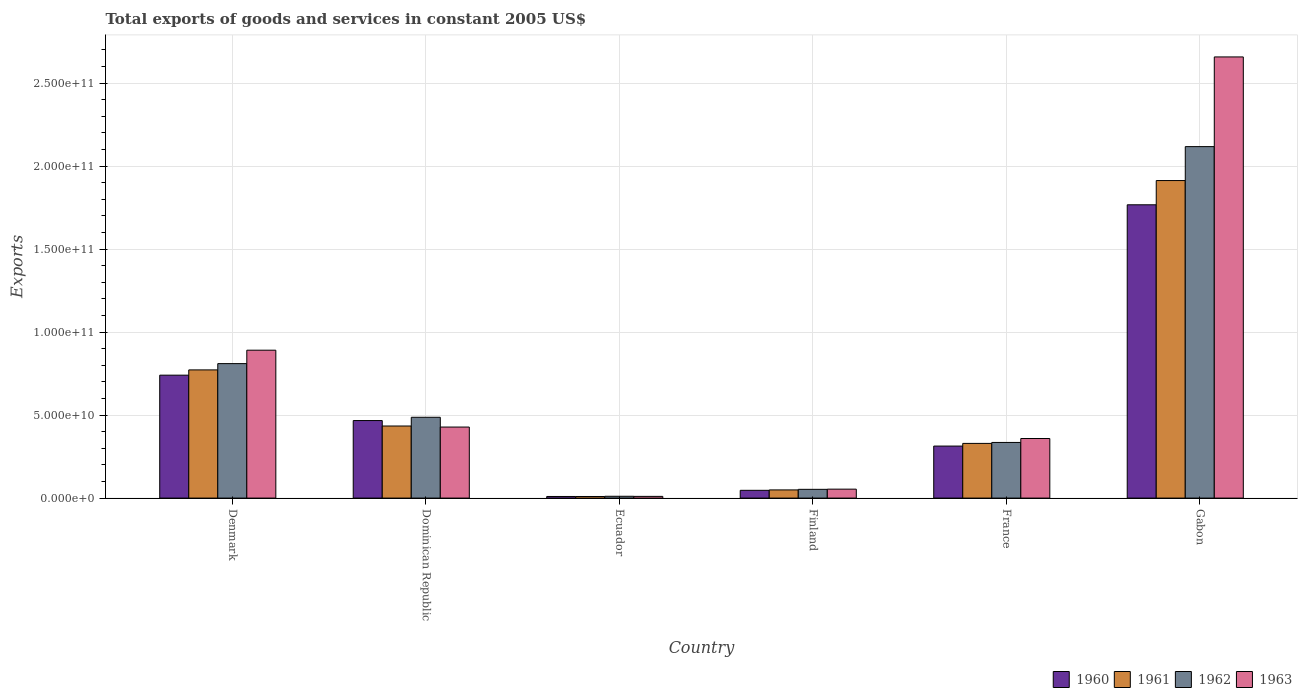How many different coloured bars are there?
Ensure brevity in your answer.  4. Are the number of bars per tick equal to the number of legend labels?
Offer a very short reply. Yes. What is the label of the 4th group of bars from the left?
Your answer should be compact. Finland. What is the total exports of goods and services in 1963 in France?
Provide a succinct answer. 3.59e+1. Across all countries, what is the maximum total exports of goods and services in 1960?
Offer a very short reply. 1.77e+11. Across all countries, what is the minimum total exports of goods and services in 1962?
Your answer should be compact. 1.09e+09. In which country was the total exports of goods and services in 1961 maximum?
Give a very brief answer. Gabon. In which country was the total exports of goods and services in 1961 minimum?
Ensure brevity in your answer.  Ecuador. What is the total total exports of goods and services in 1963 in the graph?
Keep it short and to the point. 4.40e+11. What is the difference between the total exports of goods and services in 1963 in Dominican Republic and that in France?
Provide a short and direct response. 6.90e+09. What is the difference between the total exports of goods and services in 1961 in Dominican Republic and the total exports of goods and services in 1960 in Ecuador?
Give a very brief answer. 4.24e+1. What is the average total exports of goods and services in 1962 per country?
Offer a very short reply. 6.35e+1. What is the difference between the total exports of goods and services of/in 1961 and total exports of goods and services of/in 1960 in Denmark?
Your answer should be compact. 3.17e+09. What is the ratio of the total exports of goods and services in 1962 in France to that in Gabon?
Provide a short and direct response. 0.16. What is the difference between the highest and the second highest total exports of goods and services in 1963?
Your response must be concise. -4.63e+1. What is the difference between the highest and the lowest total exports of goods and services in 1963?
Ensure brevity in your answer.  2.65e+11. Is the sum of the total exports of goods and services in 1963 in Finland and France greater than the maximum total exports of goods and services in 1960 across all countries?
Offer a terse response. No. What does the 3rd bar from the left in Dominican Republic represents?
Ensure brevity in your answer.  1962. What does the 2nd bar from the right in France represents?
Your response must be concise. 1962. How many bars are there?
Ensure brevity in your answer.  24. What is the difference between two consecutive major ticks on the Y-axis?
Your answer should be very brief. 5.00e+1. Are the values on the major ticks of Y-axis written in scientific E-notation?
Ensure brevity in your answer.  Yes. Does the graph contain any zero values?
Your response must be concise. No. Does the graph contain grids?
Your answer should be very brief. Yes. How are the legend labels stacked?
Provide a succinct answer. Horizontal. What is the title of the graph?
Offer a terse response. Total exports of goods and services in constant 2005 US$. What is the label or title of the X-axis?
Keep it short and to the point. Country. What is the label or title of the Y-axis?
Your answer should be very brief. Exports. What is the Exports in 1960 in Denmark?
Keep it short and to the point. 7.40e+1. What is the Exports of 1961 in Denmark?
Provide a short and direct response. 7.72e+1. What is the Exports of 1962 in Denmark?
Keep it short and to the point. 8.10e+1. What is the Exports in 1963 in Denmark?
Your answer should be very brief. 8.91e+1. What is the Exports of 1960 in Dominican Republic?
Give a very brief answer. 4.67e+1. What is the Exports in 1961 in Dominican Republic?
Provide a short and direct response. 4.34e+1. What is the Exports of 1962 in Dominican Republic?
Your answer should be compact. 4.87e+1. What is the Exports in 1963 in Dominican Republic?
Your answer should be compact. 4.28e+1. What is the Exports in 1960 in Ecuador?
Ensure brevity in your answer.  9.72e+08. What is the Exports of 1961 in Ecuador?
Keep it short and to the point. 9.65e+08. What is the Exports in 1962 in Ecuador?
Provide a succinct answer. 1.09e+09. What is the Exports of 1963 in Ecuador?
Provide a succinct answer. 1.03e+09. What is the Exports of 1960 in Finland?
Ensure brevity in your answer.  4.68e+09. What is the Exports in 1961 in Finland?
Make the answer very short. 4.92e+09. What is the Exports of 1962 in Finland?
Give a very brief answer. 5.27e+09. What is the Exports in 1963 in Finland?
Provide a succinct answer. 5.39e+09. What is the Exports in 1960 in France?
Make the answer very short. 3.13e+1. What is the Exports in 1961 in France?
Ensure brevity in your answer.  3.29e+1. What is the Exports in 1962 in France?
Your response must be concise. 3.35e+1. What is the Exports of 1963 in France?
Make the answer very short. 3.59e+1. What is the Exports of 1960 in Gabon?
Offer a very short reply. 1.77e+11. What is the Exports of 1961 in Gabon?
Your response must be concise. 1.91e+11. What is the Exports in 1962 in Gabon?
Make the answer very short. 2.12e+11. What is the Exports in 1963 in Gabon?
Provide a succinct answer. 2.66e+11. Across all countries, what is the maximum Exports of 1960?
Provide a succinct answer. 1.77e+11. Across all countries, what is the maximum Exports in 1961?
Keep it short and to the point. 1.91e+11. Across all countries, what is the maximum Exports of 1962?
Give a very brief answer. 2.12e+11. Across all countries, what is the maximum Exports in 1963?
Your answer should be very brief. 2.66e+11. Across all countries, what is the minimum Exports in 1960?
Offer a terse response. 9.72e+08. Across all countries, what is the minimum Exports of 1961?
Make the answer very short. 9.65e+08. Across all countries, what is the minimum Exports of 1962?
Your answer should be very brief. 1.09e+09. Across all countries, what is the minimum Exports of 1963?
Offer a terse response. 1.03e+09. What is the total Exports of 1960 in the graph?
Keep it short and to the point. 3.34e+11. What is the total Exports of 1961 in the graph?
Keep it short and to the point. 3.51e+11. What is the total Exports of 1962 in the graph?
Provide a succinct answer. 3.81e+11. What is the total Exports of 1963 in the graph?
Ensure brevity in your answer.  4.40e+11. What is the difference between the Exports of 1960 in Denmark and that in Dominican Republic?
Your answer should be compact. 2.73e+1. What is the difference between the Exports in 1961 in Denmark and that in Dominican Republic?
Give a very brief answer. 3.38e+1. What is the difference between the Exports of 1962 in Denmark and that in Dominican Republic?
Ensure brevity in your answer.  3.23e+1. What is the difference between the Exports of 1963 in Denmark and that in Dominican Republic?
Your response must be concise. 4.63e+1. What is the difference between the Exports of 1960 in Denmark and that in Ecuador?
Offer a terse response. 7.31e+1. What is the difference between the Exports of 1961 in Denmark and that in Ecuador?
Give a very brief answer. 7.62e+1. What is the difference between the Exports of 1962 in Denmark and that in Ecuador?
Make the answer very short. 7.99e+1. What is the difference between the Exports of 1963 in Denmark and that in Ecuador?
Offer a very short reply. 8.81e+1. What is the difference between the Exports in 1960 in Denmark and that in Finland?
Your answer should be compact. 6.94e+1. What is the difference between the Exports of 1961 in Denmark and that in Finland?
Make the answer very short. 7.23e+1. What is the difference between the Exports of 1962 in Denmark and that in Finland?
Your answer should be very brief. 7.57e+1. What is the difference between the Exports in 1963 in Denmark and that in Finland?
Keep it short and to the point. 8.37e+1. What is the difference between the Exports in 1960 in Denmark and that in France?
Your answer should be compact. 4.27e+1. What is the difference between the Exports of 1961 in Denmark and that in France?
Provide a short and direct response. 4.43e+1. What is the difference between the Exports in 1962 in Denmark and that in France?
Your answer should be very brief. 4.75e+1. What is the difference between the Exports of 1963 in Denmark and that in France?
Offer a terse response. 5.32e+1. What is the difference between the Exports in 1960 in Denmark and that in Gabon?
Offer a very short reply. -1.03e+11. What is the difference between the Exports in 1961 in Denmark and that in Gabon?
Provide a succinct answer. -1.14e+11. What is the difference between the Exports in 1962 in Denmark and that in Gabon?
Provide a short and direct response. -1.31e+11. What is the difference between the Exports of 1963 in Denmark and that in Gabon?
Your answer should be very brief. -1.77e+11. What is the difference between the Exports of 1960 in Dominican Republic and that in Ecuador?
Give a very brief answer. 4.57e+1. What is the difference between the Exports of 1961 in Dominican Republic and that in Ecuador?
Your response must be concise. 4.25e+1. What is the difference between the Exports in 1962 in Dominican Republic and that in Ecuador?
Your answer should be very brief. 4.76e+1. What is the difference between the Exports of 1963 in Dominican Republic and that in Ecuador?
Your response must be concise. 4.18e+1. What is the difference between the Exports in 1960 in Dominican Republic and that in Finland?
Your answer should be compact. 4.20e+1. What is the difference between the Exports of 1961 in Dominican Republic and that in Finland?
Keep it short and to the point. 3.85e+1. What is the difference between the Exports of 1962 in Dominican Republic and that in Finland?
Offer a terse response. 4.34e+1. What is the difference between the Exports in 1963 in Dominican Republic and that in Finland?
Provide a short and direct response. 3.74e+1. What is the difference between the Exports in 1960 in Dominican Republic and that in France?
Offer a terse response. 1.54e+1. What is the difference between the Exports of 1961 in Dominican Republic and that in France?
Your response must be concise. 1.05e+1. What is the difference between the Exports of 1962 in Dominican Republic and that in France?
Offer a terse response. 1.52e+1. What is the difference between the Exports of 1963 in Dominican Republic and that in France?
Your response must be concise. 6.90e+09. What is the difference between the Exports of 1960 in Dominican Republic and that in Gabon?
Make the answer very short. -1.30e+11. What is the difference between the Exports of 1961 in Dominican Republic and that in Gabon?
Offer a very short reply. -1.48e+11. What is the difference between the Exports in 1962 in Dominican Republic and that in Gabon?
Your answer should be compact. -1.63e+11. What is the difference between the Exports of 1963 in Dominican Republic and that in Gabon?
Give a very brief answer. -2.23e+11. What is the difference between the Exports of 1960 in Ecuador and that in Finland?
Make the answer very short. -3.71e+09. What is the difference between the Exports in 1961 in Ecuador and that in Finland?
Give a very brief answer. -3.96e+09. What is the difference between the Exports in 1962 in Ecuador and that in Finland?
Your answer should be compact. -4.18e+09. What is the difference between the Exports in 1963 in Ecuador and that in Finland?
Keep it short and to the point. -4.36e+09. What is the difference between the Exports in 1960 in Ecuador and that in France?
Provide a succinct answer. -3.04e+1. What is the difference between the Exports in 1961 in Ecuador and that in France?
Offer a terse response. -3.20e+1. What is the difference between the Exports of 1962 in Ecuador and that in France?
Your response must be concise. -3.24e+1. What is the difference between the Exports in 1963 in Ecuador and that in France?
Ensure brevity in your answer.  -3.49e+1. What is the difference between the Exports of 1960 in Ecuador and that in Gabon?
Your response must be concise. -1.76e+11. What is the difference between the Exports of 1961 in Ecuador and that in Gabon?
Ensure brevity in your answer.  -1.90e+11. What is the difference between the Exports in 1962 in Ecuador and that in Gabon?
Ensure brevity in your answer.  -2.11e+11. What is the difference between the Exports in 1963 in Ecuador and that in Gabon?
Ensure brevity in your answer.  -2.65e+11. What is the difference between the Exports in 1960 in Finland and that in France?
Your response must be concise. -2.67e+1. What is the difference between the Exports of 1961 in Finland and that in France?
Ensure brevity in your answer.  -2.80e+1. What is the difference between the Exports of 1962 in Finland and that in France?
Ensure brevity in your answer.  -2.83e+1. What is the difference between the Exports of 1963 in Finland and that in France?
Ensure brevity in your answer.  -3.05e+1. What is the difference between the Exports in 1960 in Finland and that in Gabon?
Make the answer very short. -1.72e+11. What is the difference between the Exports of 1961 in Finland and that in Gabon?
Ensure brevity in your answer.  -1.86e+11. What is the difference between the Exports in 1962 in Finland and that in Gabon?
Offer a terse response. -2.06e+11. What is the difference between the Exports of 1963 in Finland and that in Gabon?
Your answer should be compact. -2.60e+11. What is the difference between the Exports in 1960 in France and that in Gabon?
Make the answer very short. -1.45e+11. What is the difference between the Exports of 1961 in France and that in Gabon?
Your answer should be very brief. -1.58e+11. What is the difference between the Exports of 1962 in France and that in Gabon?
Your answer should be very brief. -1.78e+11. What is the difference between the Exports of 1963 in France and that in Gabon?
Offer a terse response. -2.30e+11. What is the difference between the Exports of 1960 in Denmark and the Exports of 1961 in Dominican Republic?
Offer a very short reply. 3.06e+1. What is the difference between the Exports of 1960 in Denmark and the Exports of 1962 in Dominican Republic?
Make the answer very short. 2.54e+1. What is the difference between the Exports in 1960 in Denmark and the Exports in 1963 in Dominican Republic?
Your response must be concise. 3.13e+1. What is the difference between the Exports in 1961 in Denmark and the Exports in 1962 in Dominican Republic?
Your answer should be compact. 2.85e+1. What is the difference between the Exports in 1961 in Denmark and the Exports in 1963 in Dominican Republic?
Make the answer very short. 3.44e+1. What is the difference between the Exports of 1962 in Denmark and the Exports of 1963 in Dominican Republic?
Make the answer very short. 3.82e+1. What is the difference between the Exports of 1960 in Denmark and the Exports of 1961 in Ecuador?
Ensure brevity in your answer.  7.31e+1. What is the difference between the Exports of 1960 in Denmark and the Exports of 1962 in Ecuador?
Your answer should be compact. 7.30e+1. What is the difference between the Exports in 1960 in Denmark and the Exports in 1963 in Ecuador?
Your response must be concise. 7.30e+1. What is the difference between the Exports in 1961 in Denmark and the Exports in 1962 in Ecuador?
Offer a very short reply. 7.61e+1. What is the difference between the Exports of 1961 in Denmark and the Exports of 1963 in Ecuador?
Give a very brief answer. 7.62e+1. What is the difference between the Exports in 1962 in Denmark and the Exports in 1963 in Ecuador?
Your answer should be compact. 8.00e+1. What is the difference between the Exports of 1960 in Denmark and the Exports of 1961 in Finland?
Your answer should be compact. 6.91e+1. What is the difference between the Exports of 1960 in Denmark and the Exports of 1962 in Finland?
Provide a short and direct response. 6.88e+1. What is the difference between the Exports in 1960 in Denmark and the Exports in 1963 in Finland?
Provide a short and direct response. 6.87e+1. What is the difference between the Exports in 1961 in Denmark and the Exports in 1962 in Finland?
Ensure brevity in your answer.  7.19e+1. What is the difference between the Exports of 1961 in Denmark and the Exports of 1963 in Finland?
Offer a very short reply. 7.18e+1. What is the difference between the Exports in 1962 in Denmark and the Exports in 1963 in Finland?
Your response must be concise. 7.56e+1. What is the difference between the Exports of 1960 in Denmark and the Exports of 1961 in France?
Keep it short and to the point. 4.11e+1. What is the difference between the Exports in 1960 in Denmark and the Exports in 1962 in France?
Ensure brevity in your answer.  4.05e+1. What is the difference between the Exports of 1960 in Denmark and the Exports of 1963 in France?
Ensure brevity in your answer.  3.82e+1. What is the difference between the Exports of 1961 in Denmark and the Exports of 1962 in France?
Provide a short and direct response. 4.37e+1. What is the difference between the Exports in 1961 in Denmark and the Exports in 1963 in France?
Give a very brief answer. 4.13e+1. What is the difference between the Exports in 1962 in Denmark and the Exports in 1963 in France?
Offer a very short reply. 4.51e+1. What is the difference between the Exports of 1960 in Denmark and the Exports of 1961 in Gabon?
Offer a terse response. -1.17e+11. What is the difference between the Exports of 1960 in Denmark and the Exports of 1962 in Gabon?
Provide a short and direct response. -1.38e+11. What is the difference between the Exports of 1960 in Denmark and the Exports of 1963 in Gabon?
Offer a very short reply. -1.92e+11. What is the difference between the Exports in 1961 in Denmark and the Exports in 1962 in Gabon?
Make the answer very short. -1.34e+11. What is the difference between the Exports in 1961 in Denmark and the Exports in 1963 in Gabon?
Offer a very short reply. -1.89e+11. What is the difference between the Exports of 1962 in Denmark and the Exports of 1963 in Gabon?
Keep it short and to the point. -1.85e+11. What is the difference between the Exports in 1960 in Dominican Republic and the Exports in 1961 in Ecuador?
Your answer should be very brief. 4.57e+1. What is the difference between the Exports of 1960 in Dominican Republic and the Exports of 1962 in Ecuador?
Your answer should be compact. 4.56e+1. What is the difference between the Exports in 1960 in Dominican Republic and the Exports in 1963 in Ecuador?
Keep it short and to the point. 4.57e+1. What is the difference between the Exports of 1961 in Dominican Republic and the Exports of 1962 in Ecuador?
Ensure brevity in your answer.  4.23e+1. What is the difference between the Exports of 1961 in Dominican Republic and the Exports of 1963 in Ecuador?
Provide a short and direct response. 4.24e+1. What is the difference between the Exports of 1962 in Dominican Republic and the Exports of 1963 in Ecuador?
Provide a succinct answer. 4.77e+1. What is the difference between the Exports of 1960 in Dominican Republic and the Exports of 1961 in Finland?
Keep it short and to the point. 4.18e+1. What is the difference between the Exports of 1960 in Dominican Republic and the Exports of 1962 in Finland?
Provide a succinct answer. 4.14e+1. What is the difference between the Exports in 1960 in Dominican Republic and the Exports in 1963 in Finland?
Your response must be concise. 4.13e+1. What is the difference between the Exports of 1961 in Dominican Republic and the Exports of 1962 in Finland?
Offer a very short reply. 3.81e+1. What is the difference between the Exports of 1961 in Dominican Republic and the Exports of 1963 in Finland?
Offer a terse response. 3.80e+1. What is the difference between the Exports of 1962 in Dominican Republic and the Exports of 1963 in Finland?
Offer a very short reply. 4.33e+1. What is the difference between the Exports in 1960 in Dominican Republic and the Exports in 1961 in France?
Offer a terse response. 1.38e+1. What is the difference between the Exports in 1960 in Dominican Republic and the Exports in 1962 in France?
Your answer should be compact. 1.32e+1. What is the difference between the Exports of 1960 in Dominican Republic and the Exports of 1963 in France?
Give a very brief answer. 1.08e+1. What is the difference between the Exports in 1961 in Dominican Republic and the Exports in 1962 in France?
Give a very brief answer. 9.89e+09. What is the difference between the Exports in 1961 in Dominican Republic and the Exports in 1963 in France?
Your answer should be compact. 7.53e+09. What is the difference between the Exports of 1962 in Dominican Republic and the Exports of 1963 in France?
Your answer should be very brief. 1.28e+1. What is the difference between the Exports in 1960 in Dominican Republic and the Exports in 1961 in Gabon?
Your answer should be very brief. -1.45e+11. What is the difference between the Exports in 1960 in Dominican Republic and the Exports in 1962 in Gabon?
Give a very brief answer. -1.65e+11. What is the difference between the Exports of 1960 in Dominican Republic and the Exports of 1963 in Gabon?
Keep it short and to the point. -2.19e+11. What is the difference between the Exports in 1961 in Dominican Republic and the Exports in 1962 in Gabon?
Provide a succinct answer. -1.68e+11. What is the difference between the Exports of 1961 in Dominican Republic and the Exports of 1963 in Gabon?
Give a very brief answer. -2.22e+11. What is the difference between the Exports of 1962 in Dominican Republic and the Exports of 1963 in Gabon?
Your answer should be compact. -2.17e+11. What is the difference between the Exports in 1960 in Ecuador and the Exports in 1961 in Finland?
Offer a terse response. -3.95e+09. What is the difference between the Exports in 1960 in Ecuador and the Exports in 1962 in Finland?
Give a very brief answer. -4.30e+09. What is the difference between the Exports in 1960 in Ecuador and the Exports in 1963 in Finland?
Ensure brevity in your answer.  -4.41e+09. What is the difference between the Exports of 1961 in Ecuador and the Exports of 1962 in Finland?
Your response must be concise. -4.31e+09. What is the difference between the Exports in 1961 in Ecuador and the Exports in 1963 in Finland?
Your response must be concise. -4.42e+09. What is the difference between the Exports in 1962 in Ecuador and the Exports in 1963 in Finland?
Give a very brief answer. -4.29e+09. What is the difference between the Exports of 1960 in Ecuador and the Exports of 1961 in France?
Offer a very short reply. -3.20e+1. What is the difference between the Exports of 1960 in Ecuador and the Exports of 1962 in France?
Keep it short and to the point. -3.25e+1. What is the difference between the Exports in 1960 in Ecuador and the Exports in 1963 in France?
Make the answer very short. -3.49e+1. What is the difference between the Exports of 1961 in Ecuador and the Exports of 1962 in France?
Provide a succinct answer. -3.26e+1. What is the difference between the Exports of 1961 in Ecuador and the Exports of 1963 in France?
Provide a short and direct response. -3.49e+1. What is the difference between the Exports in 1962 in Ecuador and the Exports in 1963 in France?
Provide a succinct answer. -3.48e+1. What is the difference between the Exports of 1960 in Ecuador and the Exports of 1961 in Gabon?
Offer a very short reply. -1.90e+11. What is the difference between the Exports in 1960 in Ecuador and the Exports in 1962 in Gabon?
Offer a terse response. -2.11e+11. What is the difference between the Exports of 1960 in Ecuador and the Exports of 1963 in Gabon?
Your answer should be compact. -2.65e+11. What is the difference between the Exports in 1961 in Ecuador and the Exports in 1962 in Gabon?
Your answer should be compact. -2.11e+11. What is the difference between the Exports of 1961 in Ecuador and the Exports of 1963 in Gabon?
Provide a succinct answer. -2.65e+11. What is the difference between the Exports of 1962 in Ecuador and the Exports of 1963 in Gabon?
Offer a very short reply. -2.65e+11. What is the difference between the Exports of 1960 in Finland and the Exports of 1961 in France?
Make the answer very short. -2.83e+1. What is the difference between the Exports of 1960 in Finland and the Exports of 1962 in France?
Provide a succinct answer. -2.88e+1. What is the difference between the Exports in 1960 in Finland and the Exports in 1963 in France?
Keep it short and to the point. -3.12e+1. What is the difference between the Exports in 1961 in Finland and the Exports in 1962 in France?
Ensure brevity in your answer.  -2.86e+1. What is the difference between the Exports of 1961 in Finland and the Exports of 1963 in France?
Provide a short and direct response. -3.10e+1. What is the difference between the Exports of 1962 in Finland and the Exports of 1963 in France?
Your response must be concise. -3.06e+1. What is the difference between the Exports in 1960 in Finland and the Exports in 1961 in Gabon?
Your answer should be very brief. -1.87e+11. What is the difference between the Exports in 1960 in Finland and the Exports in 1962 in Gabon?
Your answer should be very brief. -2.07e+11. What is the difference between the Exports of 1960 in Finland and the Exports of 1963 in Gabon?
Your answer should be compact. -2.61e+11. What is the difference between the Exports of 1961 in Finland and the Exports of 1962 in Gabon?
Offer a terse response. -2.07e+11. What is the difference between the Exports of 1961 in Finland and the Exports of 1963 in Gabon?
Provide a short and direct response. -2.61e+11. What is the difference between the Exports in 1962 in Finland and the Exports in 1963 in Gabon?
Ensure brevity in your answer.  -2.60e+11. What is the difference between the Exports in 1960 in France and the Exports in 1961 in Gabon?
Your answer should be very brief. -1.60e+11. What is the difference between the Exports of 1960 in France and the Exports of 1962 in Gabon?
Your answer should be very brief. -1.80e+11. What is the difference between the Exports in 1960 in France and the Exports in 1963 in Gabon?
Your answer should be very brief. -2.34e+11. What is the difference between the Exports in 1961 in France and the Exports in 1962 in Gabon?
Make the answer very short. -1.79e+11. What is the difference between the Exports of 1961 in France and the Exports of 1963 in Gabon?
Make the answer very short. -2.33e+11. What is the difference between the Exports of 1962 in France and the Exports of 1963 in Gabon?
Keep it short and to the point. -2.32e+11. What is the average Exports in 1960 per country?
Keep it short and to the point. 5.57e+1. What is the average Exports of 1961 per country?
Offer a terse response. 5.85e+1. What is the average Exports of 1962 per country?
Give a very brief answer. 6.35e+1. What is the average Exports of 1963 per country?
Your answer should be very brief. 7.33e+1. What is the difference between the Exports in 1960 and Exports in 1961 in Denmark?
Your response must be concise. -3.17e+09. What is the difference between the Exports in 1960 and Exports in 1962 in Denmark?
Make the answer very short. -6.96e+09. What is the difference between the Exports of 1960 and Exports of 1963 in Denmark?
Your answer should be compact. -1.50e+1. What is the difference between the Exports in 1961 and Exports in 1962 in Denmark?
Offer a terse response. -3.79e+09. What is the difference between the Exports in 1961 and Exports in 1963 in Denmark?
Make the answer very short. -1.19e+1. What is the difference between the Exports in 1962 and Exports in 1963 in Denmark?
Your answer should be compact. -8.08e+09. What is the difference between the Exports in 1960 and Exports in 1961 in Dominican Republic?
Keep it short and to the point. 3.29e+09. What is the difference between the Exports in 1960 and Exports in 1962 in Dominican Republic?
Make the answer very short. -1.98e+09. What is the difference between the Exports of 1960 and Exports of 1963 in Dominican Republic?
Provide a succinct answer. 3.92e+09. What is the difference between the Exports in 1961 and Exports in 1962 in Dominican Republic?
Give a very brief answer. -5.27e+09. What is the difference between the Exports of 1961 and Exports of 1963 in Dominican Republic?
Your answer should be compact. 6.26e+08. What is the difference between the Exports in 1962 and Exports in 1963 in Dominican Republic?
Provide a succinct answer. 5.89e+09. What is the difference between the Exports of 1960 and Exports of 1961 in Ecuador?
Your response must be concise. 7.18e+06. What is the difference between the Exports of 1960 and Exports of 1962 in Ecuador?
Give a very brief answer. -1.22e+08. What is the difference between the Exports in 1960 and Exports in 1963 in Ecuador?
Provide a succinct answer. -5.99e+07. What is the difference between the Exports of 1961 and Exports of 1962 in Ecuador?
Your response must be concise. -1.29e+08. What is the difference between the Exports of 1961 and Exports of 1963 in Ecuador?
Give a very brief answer. -6.70e+07. What is the difference between the Exports of 1962 and Exports of 1963 in Ecuador?
Make the answer very short. 6.23e+07. What is the difference between the Exports in 1960 and Exports in 1961 in Finland?
Your answer should be very brief. -2.41e+08. What is the difference between the Exports in 1960 and Exports in 1962 in Finland?
Give a very brief answer. -5.89e+08. What is the difference between the Exports in 1960 and Exports in 1963 in Finland?
Give a very brief answer. -7.04e+08. What is the difference between the Exports in 1961 and Exports in 1962 in Finland?
Your answer should be compact. -3.48e+08. What is the difference between the Exports in 1961 and Exports in 1963 in Finland?
Ensure brevity in your answer.  -4.64e+08. What is the difference between the Exports in 1962 and Exports in 1963 in Finland?
Offer a very short reply. -1.15e+08. What is the difference between the Exports of 1960 and Exports of 1961 in France?
Keep it short and to the point. -1.60e+09. What is the difference between the Exports in 1960 and Exports in 1962 in France?
Your answer should be compact. -2.19e+09. What is the difference between the Exports in 1960 and Exports in 1963 in France?
Your answer should be very brief. -4.55e+09. What is the difference between the Exports of 1961 and Exports of 1962 in France?
Your answer should be compact. -5.82e+08. What is the difference between the Exports of 1961 and Exports of 1963 in France?
Your response must be concise. -2.95e+09. What is the difference between the Exports in 1962 and Exports in 1963 in France?
Give a very brief answer. -2.37e+09. What is the difference between the Exports in 1960 and Exports in 1961 in Gabon?
Your response must be concise. -1.46e+1. What is the difference between the Exports of 1960 and Exports of 1962 in Gabon?
Your answer should be very brief. -3.50e+1. What is the difference between the Exports of 1960 and Exports of 1963 in Gabon?
Provide a succinct answer. -8.91e+1. What is the difference between the Exports of 1961 and Exports of 1962 in Gabon?
Give a very brief answer. -2.04e+1. What is the difference between the Exports of 1961 and Exports of 1963 in Gabon?
Your response must be concise. -7.45e+1. What is the difference between the Exports of 1962 and Exports of 1963 in Gabon?
Your answer should be very brief. -5.40e+1. What is the ratio of the Exports of 1960 in Denmark to that in Dominican Republic?
Offer a terse response. 1.59. What is the ratio of the Exports of 1961 in Denmark to that in Dominican Republic?
Offer a very short reply. 1.78. What is the ratio of the Exports of 1962 in Denmark to that in Dominican Republic?
Provide a short and direct response. 1.66. What is the ratio of the Exports of 1963 in Denmark to that in Dominican Republic?
Your response must be concise. 2.08. What is the ratio of the Exports of 1960 in Denmark to that in Ecuador?
Provide a succinct answer. 76.17. What is the ratio of the Exports of 1961 in Denmark to that in Ecuador?
Ensure brevity in your answer.  80.01. What is the ratio of the Exports in 1962 in Denmark to that in Ecuador?
Offer a terse response. 74.02. What is the ratio of the Exports of 1963 in Denmark to that in Ecuador?
Offer a very short reply. 86.32. What is the ratio of the Exports of 1960 in Denmark to that in Finland?
Provide a short and direct response. 15.81. What is the ratio of the Exports in 1961 in Denmark to that in Finland?
Keep it short and to the point. 15.68. What is the ratio of the Exports in 1962 in Denmark to that in Finland?
Ensure brevity in your answer.  15.37. What is the ratio of the Exports of 1963 in Denmark to that in Finland?
Offer a terse response. 16.54. What is the ratio of the Exports in 1960 in Denmark to that in France?
Give a very brief answer. 2.36. What is the ratio of the Exports of 1961 in Denmark to that in France?
Your answer should be compact. 2.34. What is the ratio of the Exports of 1962 in Denmark to that in France?
Your response must be concise. 2.42. What is the ratio of the Exports in 1963 in Denmark to that in France?
Ensure brevity in your answer.  2.48. What is the ratio of the Exports of 1960 in Denmark to that in Gabon?
Your answer should be very brief. 0.42. What is the ratio of the Exports of 1961 in Denmark to that in Gabon?
Offer a very short reply. 0.4. What is the ratio of the Exports of 1962 in Denmark to that in Gabon?
Your answer should be compact. 0.38. What is the ratio of the Exports of 1963 in Denmark to that in Gabon?
Make the answer very short. 0.34. What is the ratio of the Exports in 1960 in Dominican Republic to that in Ecuador?
Your answer should be very brief. 48.04. What is the ratio of the Exports of 1961 in Dominican Republic to that in Ecuador?
Give a very brief answer. 44.99. What is the ratio of the Exports in 1962 in Dominican Republic to that in Ecuador?
Offer a very short reply. 44.49. What is the ratio of the Exports in 1963 in Dominican Republic to that in Ecuador?
Offer a very short reply. 41.46. What is the ratio of the Exports in 1960 in Dominican Republic to that in Finland?
Offer a terse response. 9.97. What is the ratio of the Exports of 1961 in Dominican Republic to that in Finland?
Your response must be concise. 8.82. What is the ratio of the Exports in 1962 in Dominican Republic to that in Finland?
Your response must be concise. 9.23. What is the ratio of the Exports of 1963 in Dominican Republic to that in Finland?
Offer a very short reply. 7.94. What is the ratio of the Exports in 1960 in Dominican Republic to that in France?
Make the answer very short. 1.49. What is the ratio of the Exports of 1961 in Dominican Republic to that in France?
Keep it short and to the point. 1.32. What is the ratio of the Exports in 1962 in Dominican Republic to that in France?
Give a very brief answer. 1.45. What is the ratio of the Exports of 1963 in Dominican Republic to that in France?
Your answer should be very brief. 1.19. What is the ratio of the Exports in 1960 in Dominican Republic to that in Gabon?
Your answer should be very brief. 0.26. What is the ratio of the Exports of 1961 in Dominican Republic to that in Gabon?
Your response must be concise. 0.23. What is the ratio of the Exports in 1962 in Dominican Republic to that in Gabon?
Your response must be concise. 0.23. What is the ratio of the Exports of 1963 in Dominican Republic to that in Gabon?
Offer a terse response. 0.16. What is the ratio of the Exports of 1960 in Ecuador to that in Finland?
Give a very brief answer. 0.21. What is the ratio of the Exports of 1961 in Ecuador to that in Finland?
Keep it short and to the point. 0.2. What is the ratio of the Exports of 1962 in Ecuador to that in Finland?
Your answer should be compact. 0.21. What is the ratio of the Exports in 1963 in Ecuador to that in Finland?
Keep it short and to the point. 0.19. What is the ratio of the Exports of 1960 in Ecuador to that in France?
Your answer should be compact. 0.03. What is the ratio of the Exports in 1961 in Ecuador to that in France?
Ensure brevity in your answer.  0.03. What is the ratio of the Exports of 1962 in Ecuador to that in France?
Make the answer very short. 0.03. What is the ratio of the Exports in 1963 in Ecuador to that in France?
Ensure brevity in your answer.  0.03. What is the ratio of the Exports of 1960 in Ecuador to that in Gabon?
Your answer should be very brief. 0.01. What is the ratio of the Exports in 1961 in Ecuador to that in Gabon?
Your response must be concise. 0.01. What is the ratio of the Exports of 1962 in Ecuador to that in Gabon?
Offer a very short reply. 0.01. What is the ratio of the Exports of 1963 in Ecuador to that in Gabon?
Offer a very short reply. 0. What is the ratio of the Exports of 1960 in Finland to that in France?
Provide a short and direct response. 0.15. What is the ratio of the Exports in 1961 in Finland to that in France?
Ensure brevity in your answer.  0.15. What is the ratio of the Exports in 1962 in Finland to that in France?
Offer a terse response. 0.16. What is the ratio of the Exports of 1963 in Finland to that in France?
Make the answer very short. 0.15. What is the ratio of the Exports of 1960 in Finland to that in Gabon?
Your answer should be very brief. 0.03. What is the ratio of the Exports in 1961 in Finland to that in Gabon?
Ensure brevity in your answer.  0.03. What is the ratio of the Exports of 1962 in Finland to that in Gabon?
Give a very brief answer. 0.02. What is the ratio of the Exports in 1963 in Finland to that in Gabon?
Offer a terse response. 0.02. What is the ratio of the Exports of 1960 in France to that in Gabon?
Offer a terse response. 0.18. What is the ratio of the Exports of 1961 in France to that in Gabon?
Keep it short and to the point. 0.17. What is the ratio of the Exports in 1962 in France to that in Gabon?
Provide a short and direct response. 0.16. What is the ratio of the Exports of 1963 in France to that in Gabon?
Your response must be concise. 0.14. What is the difference between the highest and the second highest Exports of 1960?
Offer a terse response. 1.03e+11. What is the difference between the highest and the second highest Exports in 1961?
Offer a very short reply. 1.14e+11. What is the difference between the highest and the second highest Exports of 1962?
Your response must be concise. 1.31e+11. What is the difference between the highest and the second highest Exports in 1963?
Provide a succinct answer. 1.77e+11. What is the difference between the highest and the lowest Exports in 1960?
Keep it short and to the point. 1.76e+11. What is the difference between the highest and the lowest Exports of 1961?
Your answer should be very brief. 1.90e+11. What is the difference between the highest and the lowest Exports of 1962?
Provide a short and direct response. 2.11e+11. What is the difference between the highest and the lowest Exports of 1963?
Provide a short and direct response. 2.65e+11. 